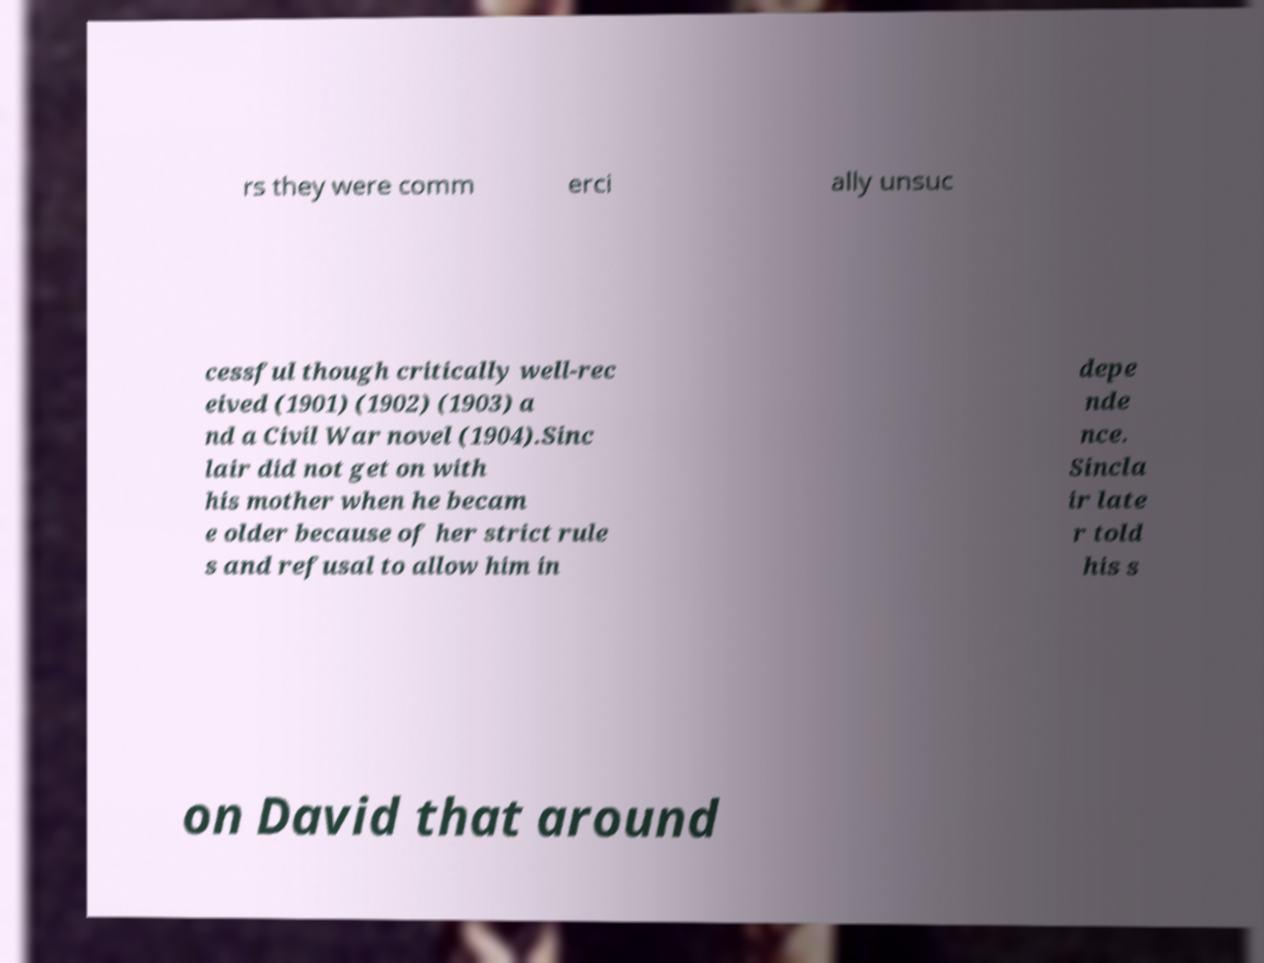Could you extract and type out the text from this image? rs they were comm erci ally unsuc cessful though critically well-rec eived (1901) (1902) (1903) a nd a Civil War novel (1904).Sinc lair did not get on with his mother when he becam e older because of her strict rule s and refusal to allow him in depe nde nce. Sincla ir late r told his s on David that around 